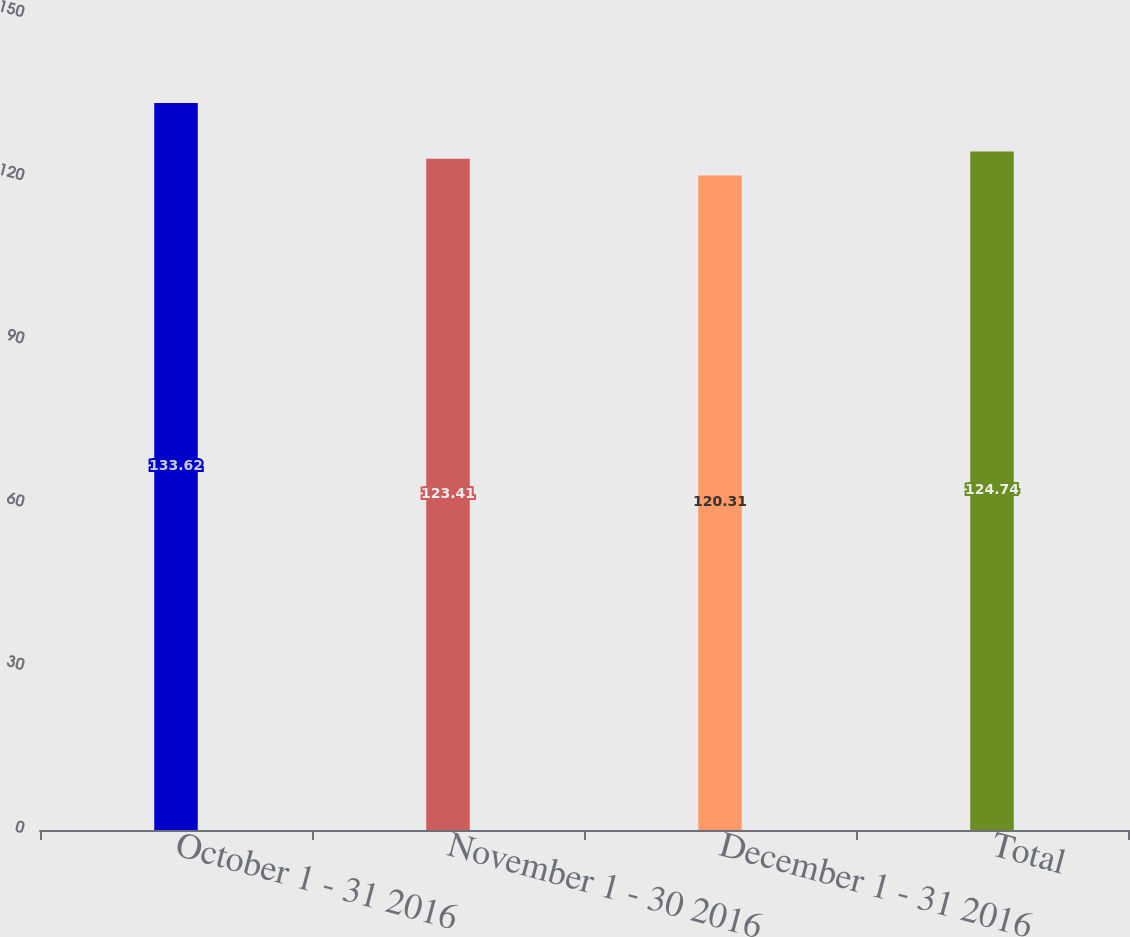<chart> <loc_0><loc_0><loc_500><loc_500><bar_chart><fcel>October 1 - 31 2016<fcel>November 1 - 30 2016<fcel>December 1 - 31 2016<fcel>Total<nl><fcel>133.62<fcel>123.41<fcel>120.31<fcel>124.74<nl></chart> 